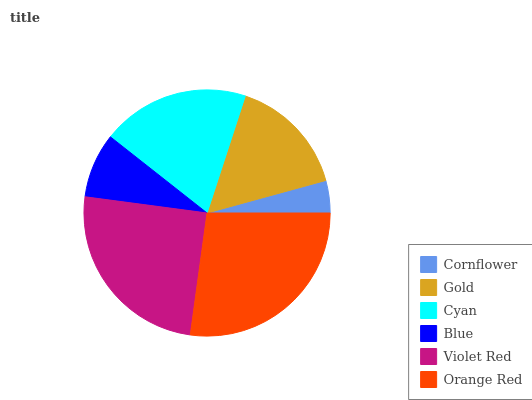Is Cornflower the minimum?
Answer yes or no. Yes. Is Orange Red the maximum?
Answer yes or no. Yes. Is Gold the minimum?
Answer yes or no. No. Is Gold the maximum?
Answer yes or no. No. Is Gold greater than Cornflower?
Answer yes or no. Yes. Is Cornflower less than Gold?
Answer yes or no. Yes. Is Cornflower greater than Gold?
Answer yes or no. No. Is Gold less than Cornflower?
Answer yes or no. No. Is Cyan the high median?
Answer yes or no. Yes. Is Gold the low median?
Answer yes or no. Yes. Is Blue the high median?
Answer yes or no. No. Is Orange Red the low median?
Answer yes or no. No. 